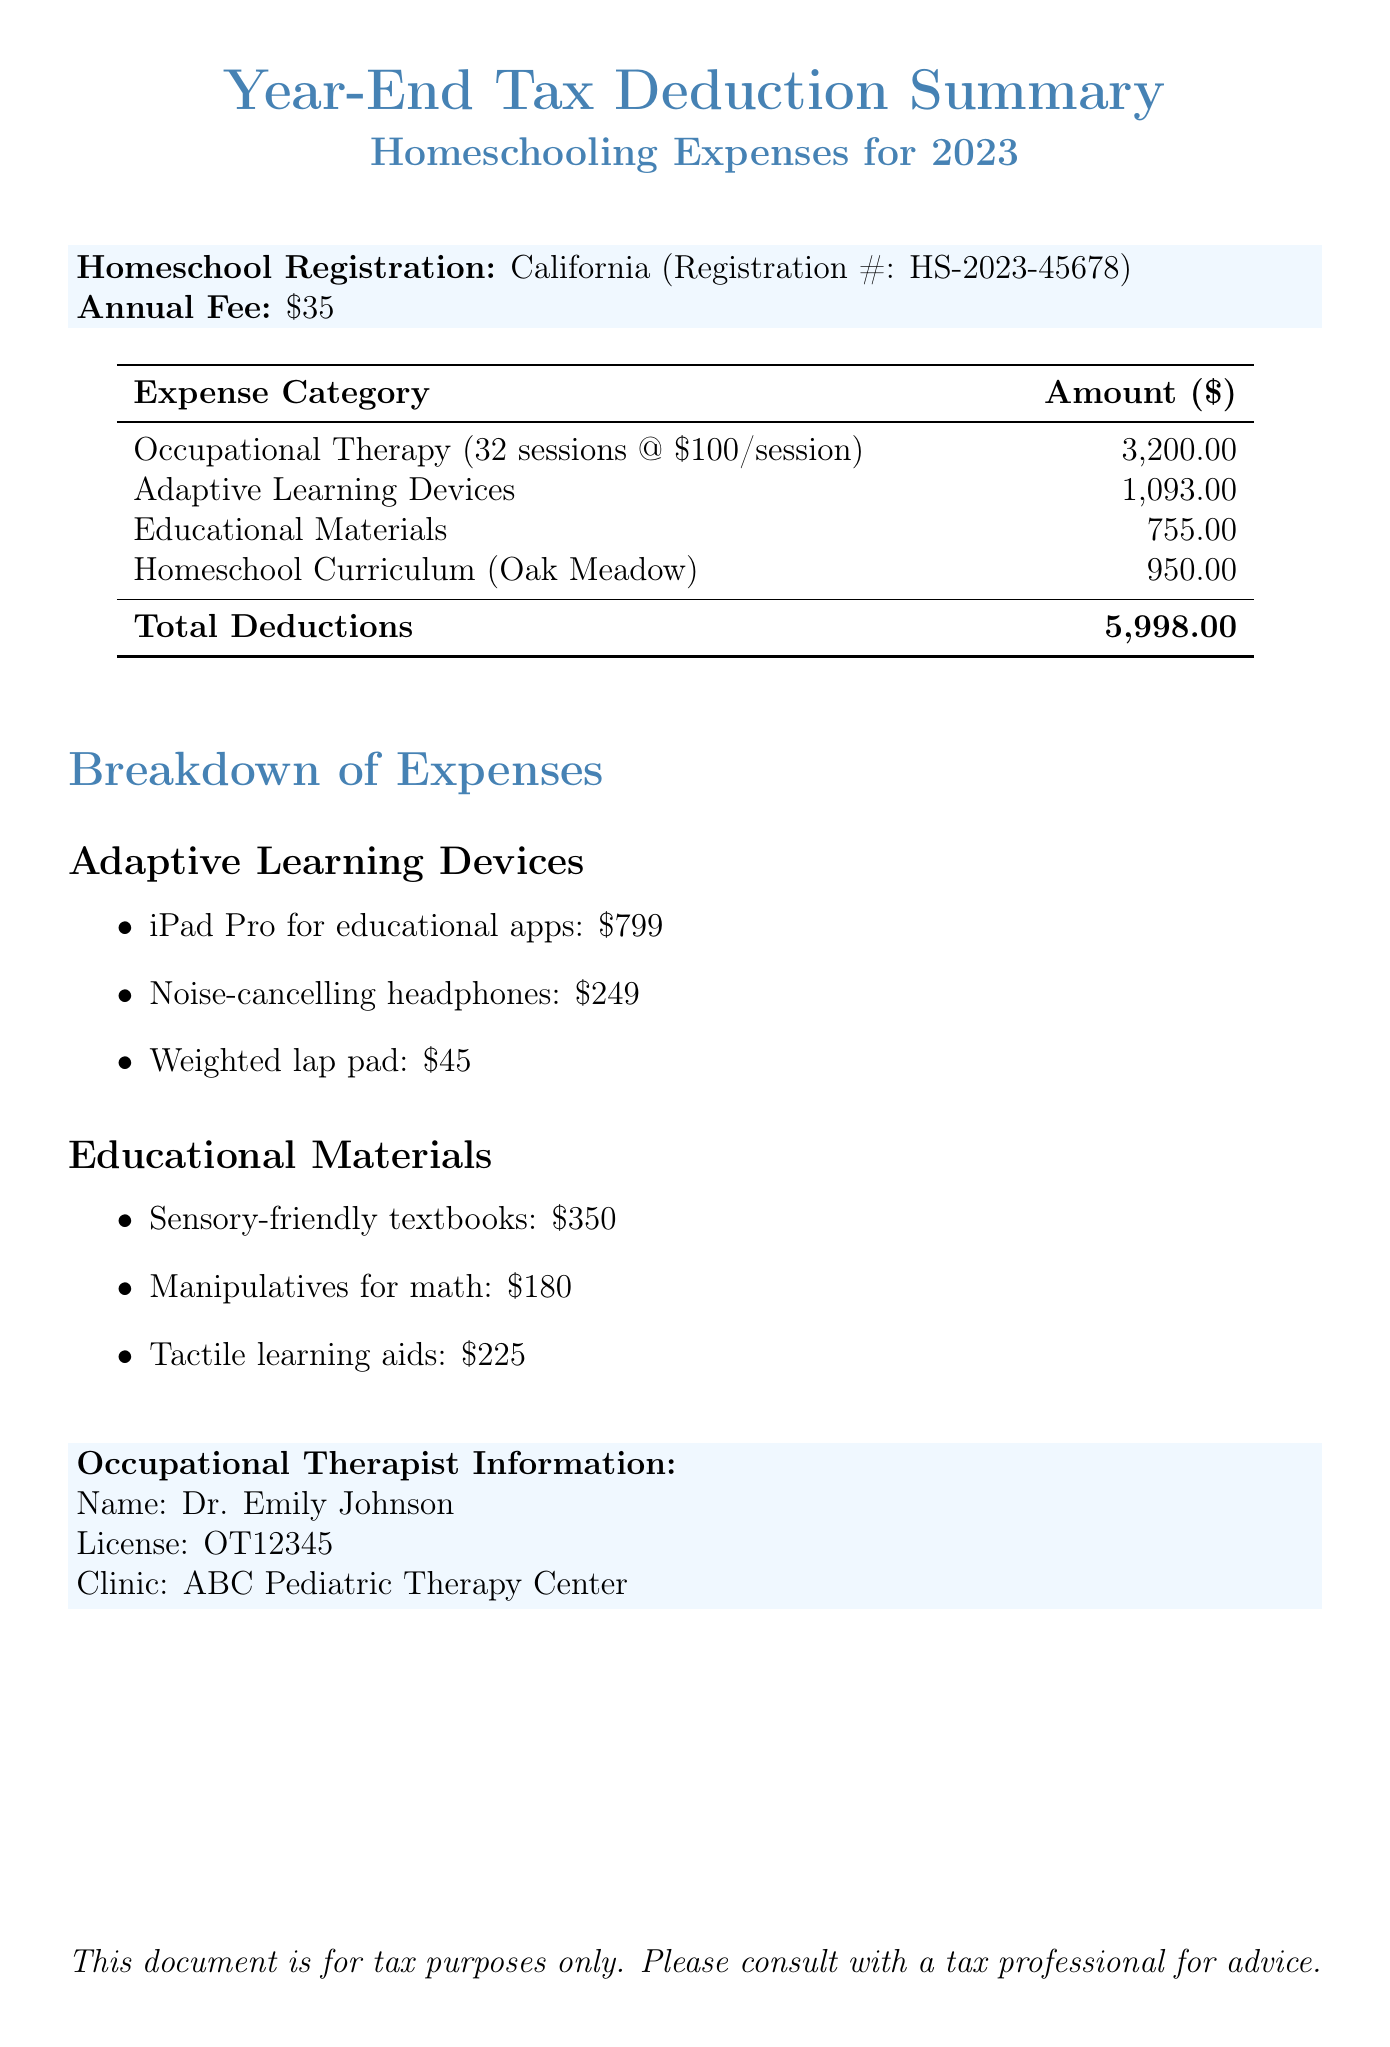What is the total amount for Occupational Therapy Sessions? The total amount for Occupational Therapy Sessions is specified as $3200 in the document.
Answer: $3200 What is the cost of the iPad Pro for educational apps? The cost of the iPad Pro for educational apps is listed as $799 in the document.
Answer: $799 How many therapy sessions were taken? The document specifies there were 32 sessions for Occupational Therapy.
Answer: 32 What is the total amount of tax deductions for 2023? The total deductions for the year 2023 is reported as $5998 in the document.
Answer: $5998 Who is the occupational therapist named in the document? The name of the occupational therapist mentioned in the document is Dr. Emily Johnson.
Answer: Dr. Emily Johnson What is the annual fee for homeschool registration? The annual fee for homeschool registration is stated as $35 in the document.
Answer: $35 How many items are listed under Adaptive Learning Devices? There are three items listed under Adaptive Learning Devices in the document.
Answer: Three What is the cost of the Noise-cancelling headphones? The cost of the Noise-cancelling headphones is stated as $249 in the document.
Answer: $249 